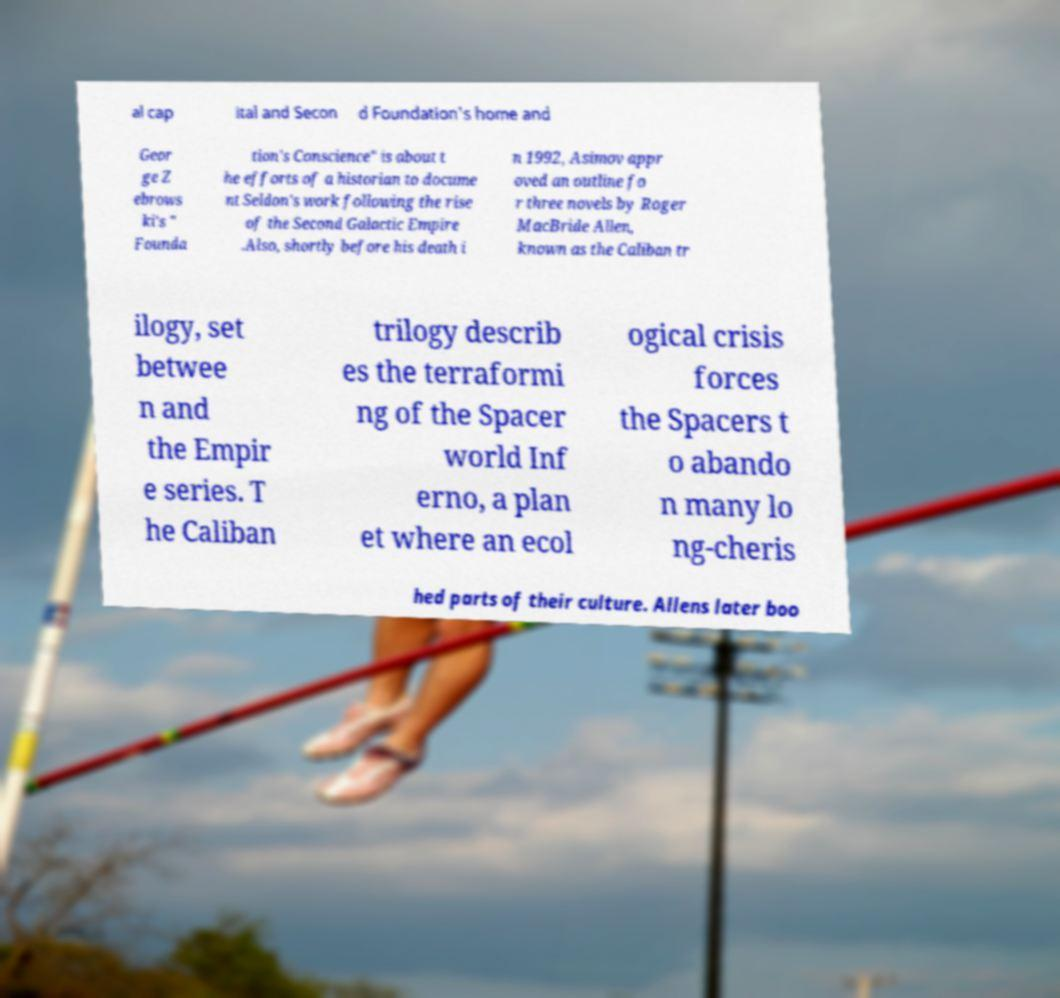Can you accurately transcribe the text from the provided image for me? al cap ital and Secon d Foundation's home and Geor ge Z ebrows ki's " Founda tion's Conscience" is about t he efforts of a historian to docume nt Seldon's work following the rise of the Second Galactic Empire .Also, shortly before his death i n 1992, Asimov appr oved an outline fo r three novels by Roger MacBride Allen, known as the Caliban tr ilogy, set betwee n and the Empir e series. T he Caliban trilogy describ es the terraformi ng of the Spacer world Inf erno, a plan et where an ecol ogical crisis forces the Spacers t o abando n many lo ng-cheris hed parts of their culture. Allens later boo 